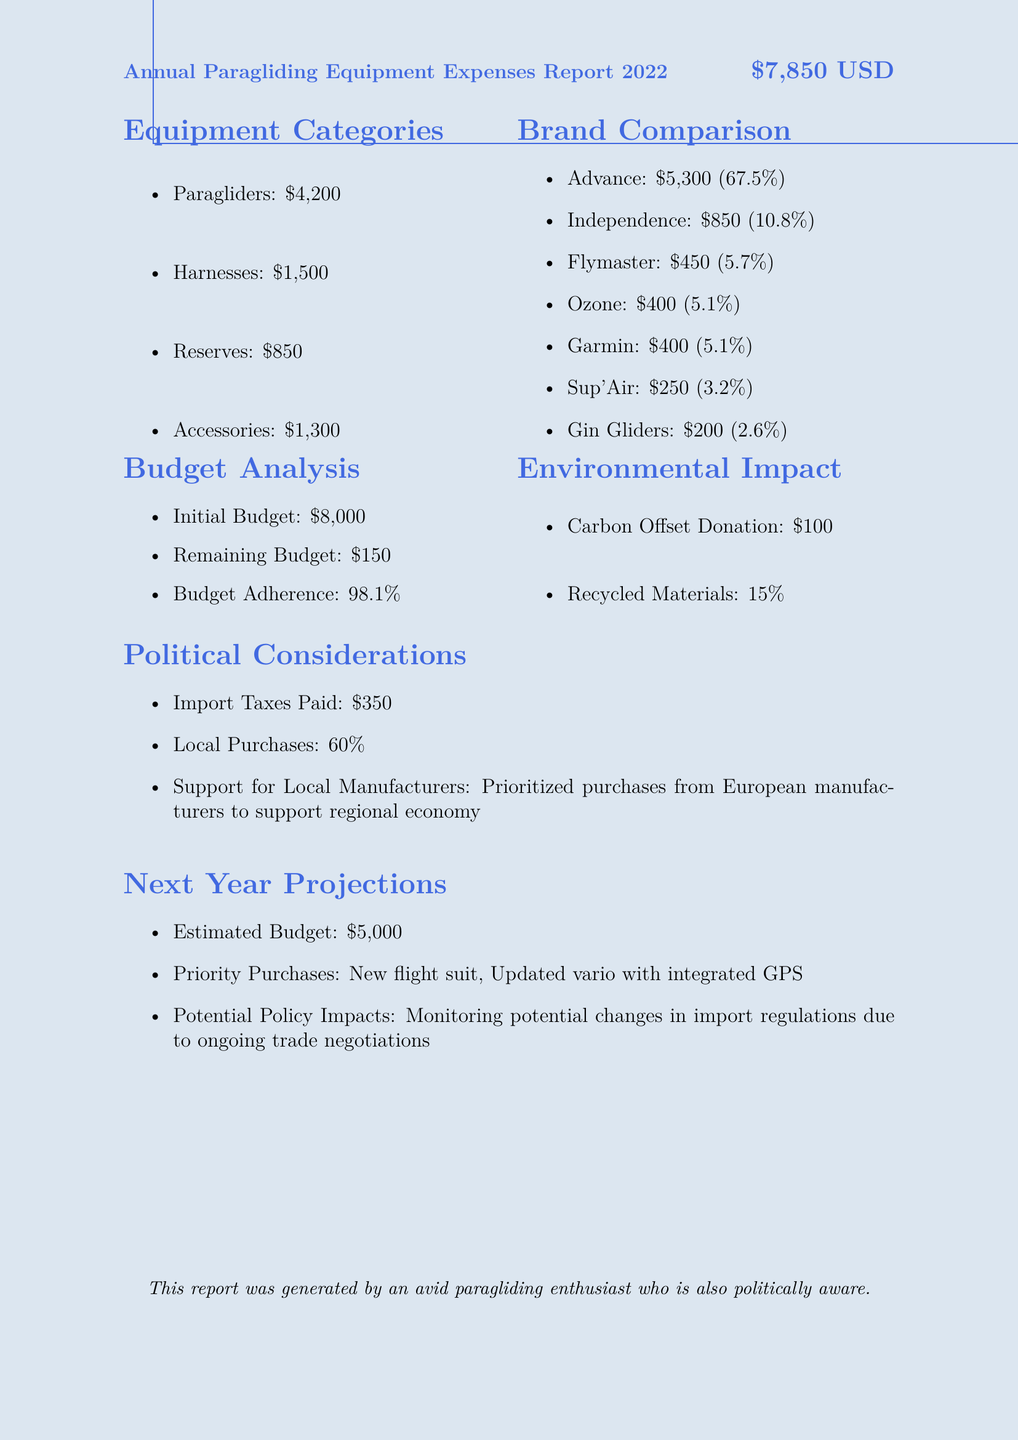What is the total spent on paragliders? The total spent on paragliders is specifically mentioned in the report, which is $4200.
Answer: $4200 Who is the brand with the highest total spent? The brand with the highest total spent is indicated as Advance, with a total of $5300.
Answer: Advance What percentage of the budget was adhered to? The budget adherence percentage is explicitly stated in the document as 98.1%.
Answer: 98.1% What was the cost of the Advance Sigma 11 model? The cost of the Advance Sigma 11 model is noted in the items list as $3800.
Answer: $3800 Which category has the lowest amount spent? The category with the lowest amount spent, as specified in the report, is reserves with a total of $850.
Answer: Reserves What is the remaining budget after expenses? The remaining budget after expenses is mentioned as $150 in the budget analysis section.
Answer: $150 What priority purchase is planned for next year? The priority purchase planned for next year is a new flight suit, as stated in the projections section.
Answer: New flight suit What was the total spent on accessories? The total spent on accessories is provided as $1300 in the equipment categories.
Answer: $1300 How much was paid in import taxes? The amount paid in import taxes is explicitly noted as $350 in the political considerations.
Answer: $350 